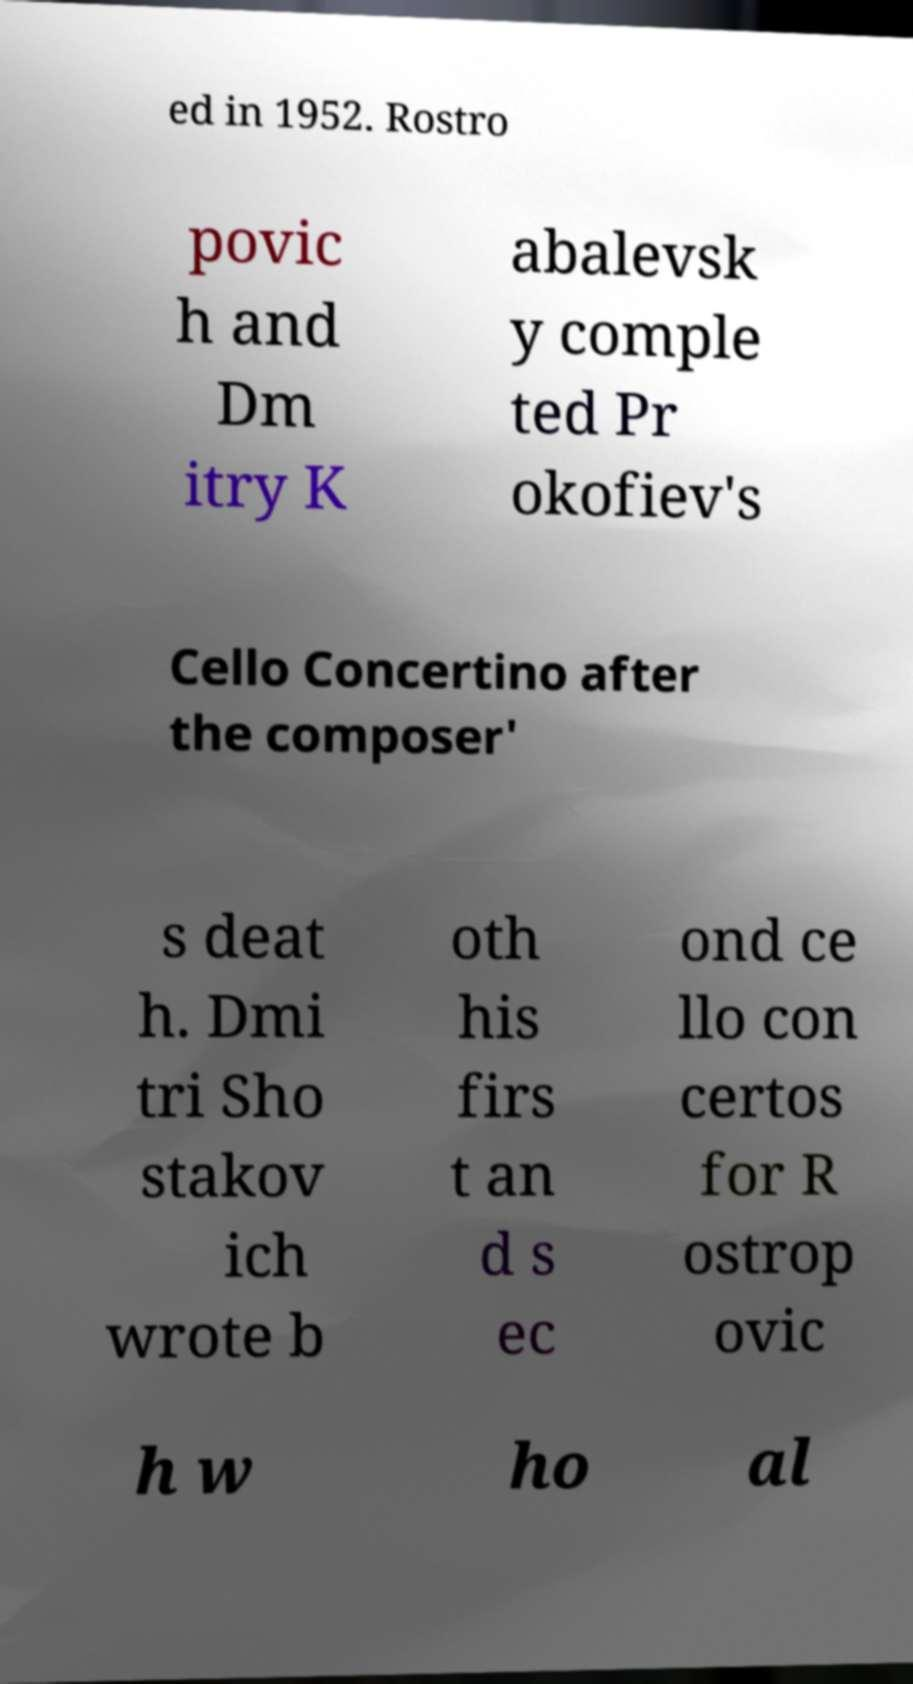Could you assist in decoding the text presented in this image and type it out clearly? ed in 1952. Rostro povic h and Dm itry K abalevsk y comple ted Pr okofiev's Cello Concertino after the composer' s deat h. Dmi tri Sho stakov ich wrote b oth his firs t an d s ec ond ce llo con certos for R ostrop ovic h w ho al 